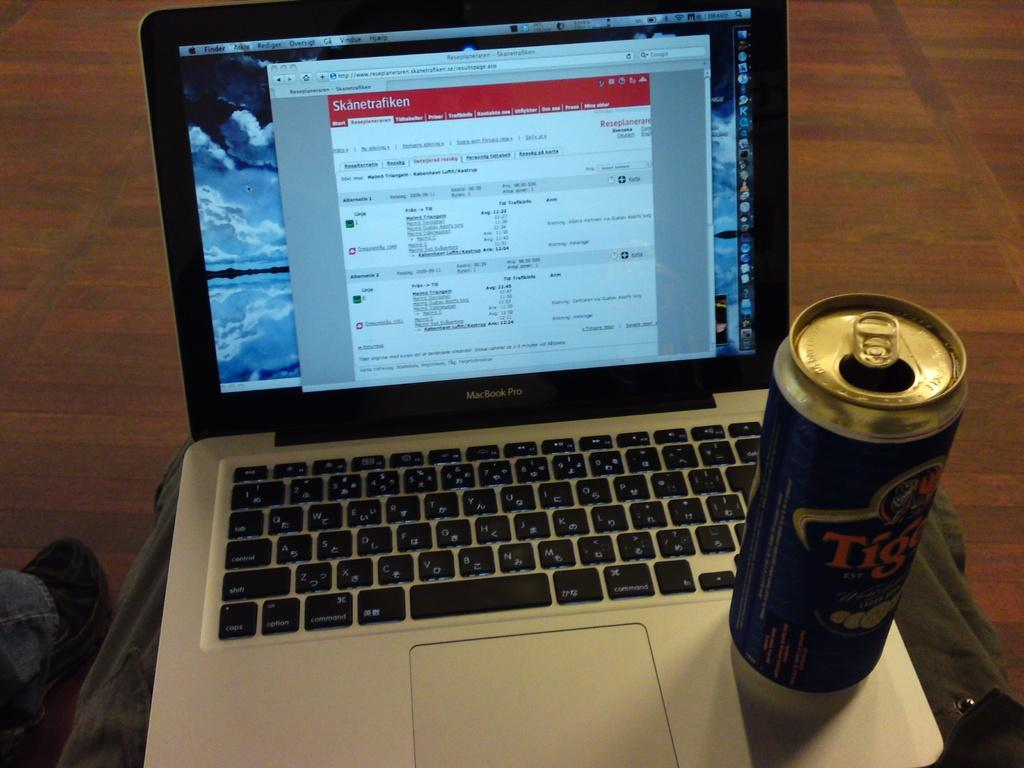<image>
Summarize the visual content of the image. A macbook laptop with an opened can of a beverage. 